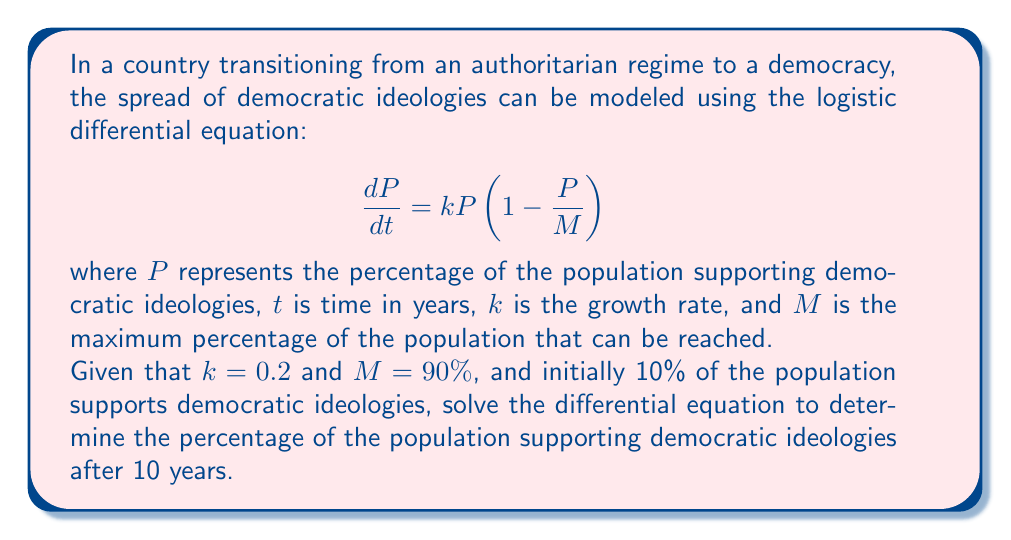What is the answer to this math problem? To solve this logistic differential equation, we'll follow these steps:

1) The general solution to the logistic differential equation is:

   $$P(t) = \frac{M}{1 + Ce^{-kMt}}$$

   where $C$ is a constant we need to determine from the initial condition.

2) We're given that initially, 10% of the population supports democratic ideologies. So at $t=0$, $P(0) = 10$. Let's use this to find $C$:

   $$10 = \frac{90}{1 + C}$$

   $$1 + C = 9$$
   
   $$C = 8$$

3) Now we have our specific solution:

   $$P(t) = \frac{90}{1 + 8e^{-18t}}$$

4) To find the percentage after 10 years, we substitute $t = 10$:

   $$P(10) = \frac{90}{1 + 8e^{-18(10)}}$$

5) Simplify:
   
   $$P(10) = \frac{90}{1 + 8e^{-180}}$$
   
   $$P(10) = \frac{90}{1 + 8(2.5 \times 10^{-79})}$$
   
   $$P(10) \approx 89.99999999999999\%$$

Therefore, after 10 years, approximately 90% of the population will support democratic ideologies.
Answer: After 10 years, approximately 90% of the population will support democratic ideologies. 